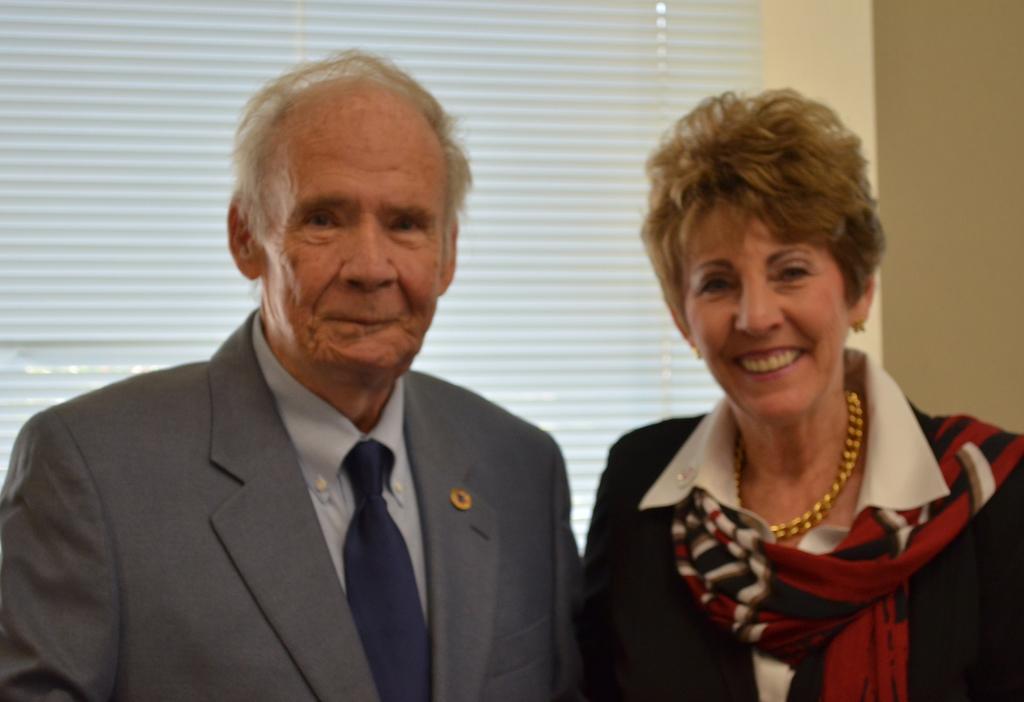How would you summarize this image in a sentence or two? In the image we can see there are people standing and behind there is blind on the window. 